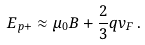Convert formula to latex. <formula><loc_0><loc_0><loc_500><loc_500>E _ { p + } \approx \mu _ { 0 } B + \frac { 2 } { 3 } q v _ { F } \, .</formula> 